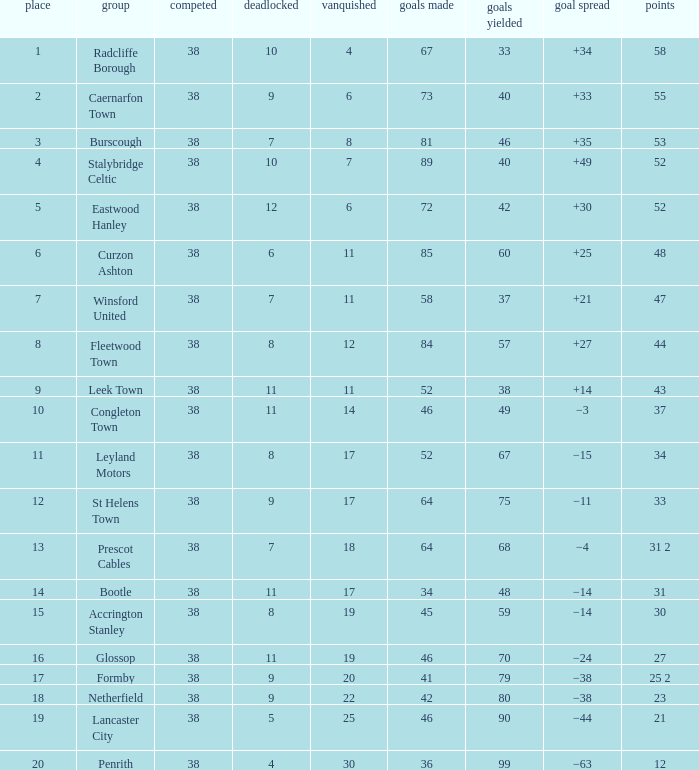WHAT IS THE LOST WITH A DRAWN 11, FOR LEEK TOWN? 11.0. 